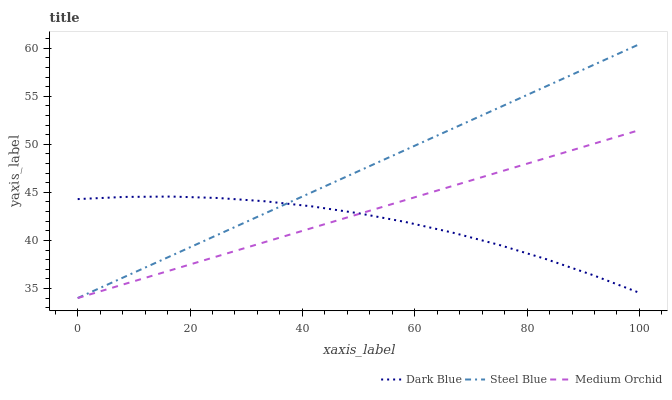Does Dark Blue have the minimum area under the curve?
Answer yes or no. Yes. Does Steel Blue have the maximum area under the curve?
Answer yes or no. Yes. Does Medium Orchid have the minimum area under the curve?
Answer yes or no. No. Does Medium Orchid have the maximum area under the curve?
Answer yes or no. No. Is Steel Blue the smoothest?
Answer yes or no. Yes. Is Dark Blue the roughest?
Answer yes or no. Yes. Is Medium Orchid the smoothest?
Answer yes or no. No. Is Medium Orchid the roughest?
Answer yes or no. No. Does Medium Orchid have the lowest value?
Answer yes or no. Yes. Does Steel Blue have the highest value?
Answer yes or no. Yes. Does Medium Orchid have the highest value?
Answer yes or no. No. Does Dark Blue intersect Medium Orchid?
Answer yes or no. Yes. Is Dark Blue less than Medium Orchid?
Answer yes or no. No. Is Dark Blue greater than Medium Orchid?
Answer yes or no. No. 